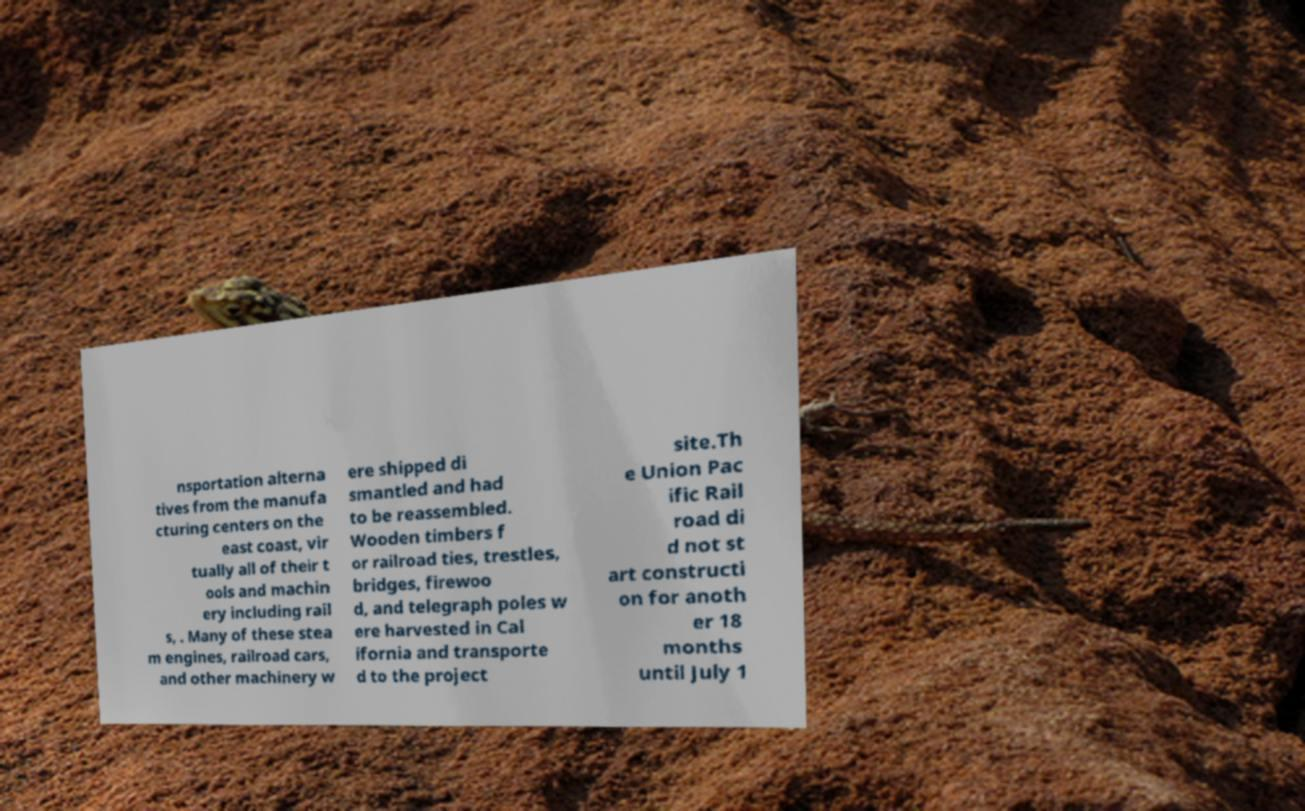I need the written content from this picture converted into text. Can you do that? nsportation alterna tives from the manufa cturing centers on the east coast, vir tually all of their t ools and machin ery including rail s, . Many of these stea m engines, railroad cars, and other machinery w ere shipped di smantled and had to be reassembled. Wooden timbers f or railroad ties, trestles, bridges, firewoo d, and telegraph poles w ere harvested in Cal ifornia and transporte d to the project site.Th e Union Pac ific Rail road di d not st art constructi on for anoth er 18 months until July 1 